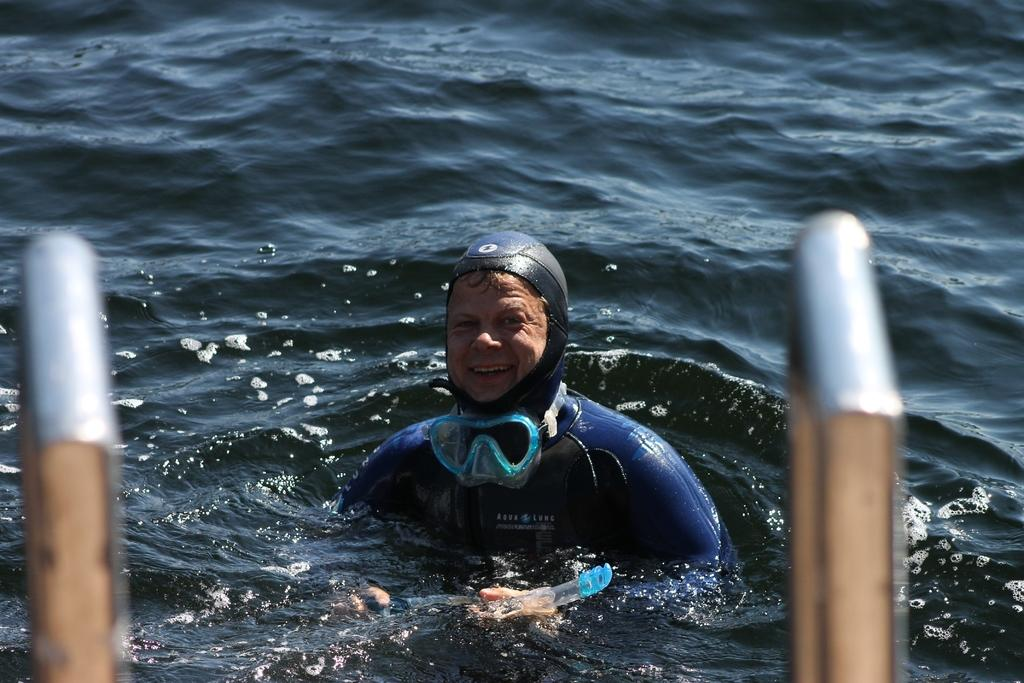What is the person in the image doing? The person is in the water, wearing a swimsuit and goggles, and appears to be swimming or playing. What is the person's facial expression in the image? The person is smiling in the image. What can be seen on either side of the image? There are two stainless steel rods on either side of the image. What type of paste is being used to stick the card to the person's care in the image? There is no card, paste, or care present in the image; it features a person swimming or playing in the water. 